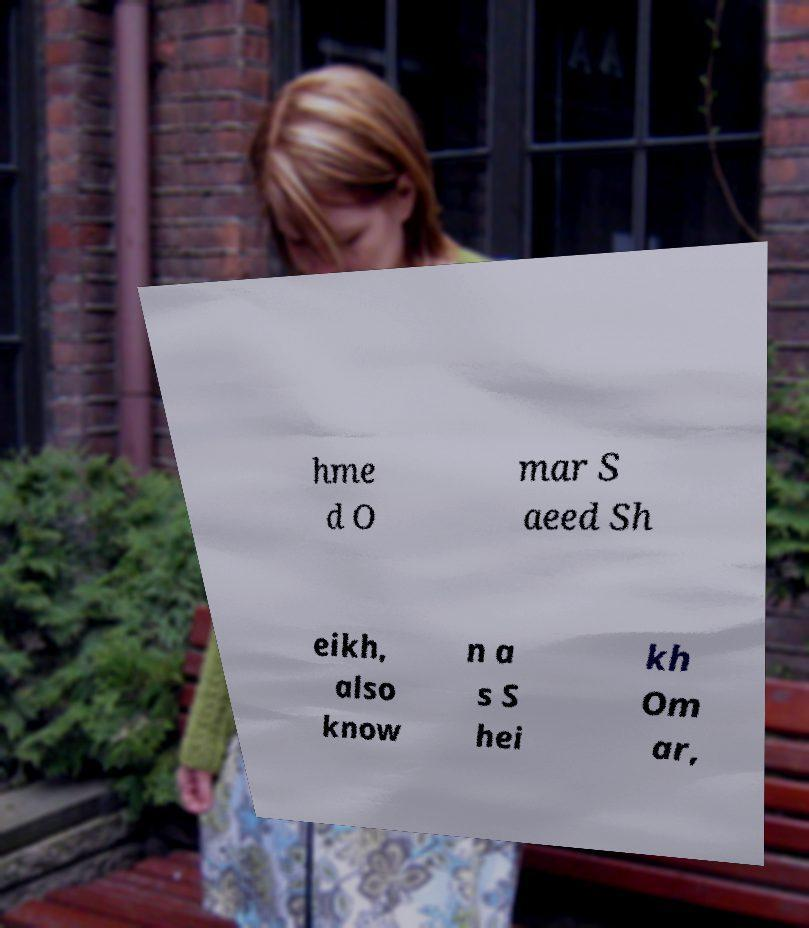Can you accurately transcribe the text from the provided image for me? hme d O mar S aeed Sh eikh, also know n a s S hei kh Om ar, 